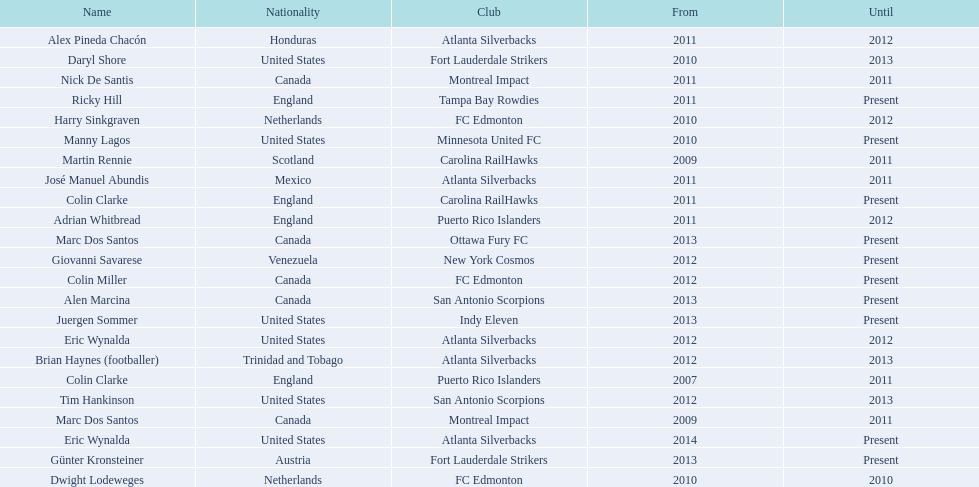What year did marc dos santos start as coach? 2009. Which other starting years correspond with this year? 2009. Who was the other coach with this starting year Martin Rennie. 